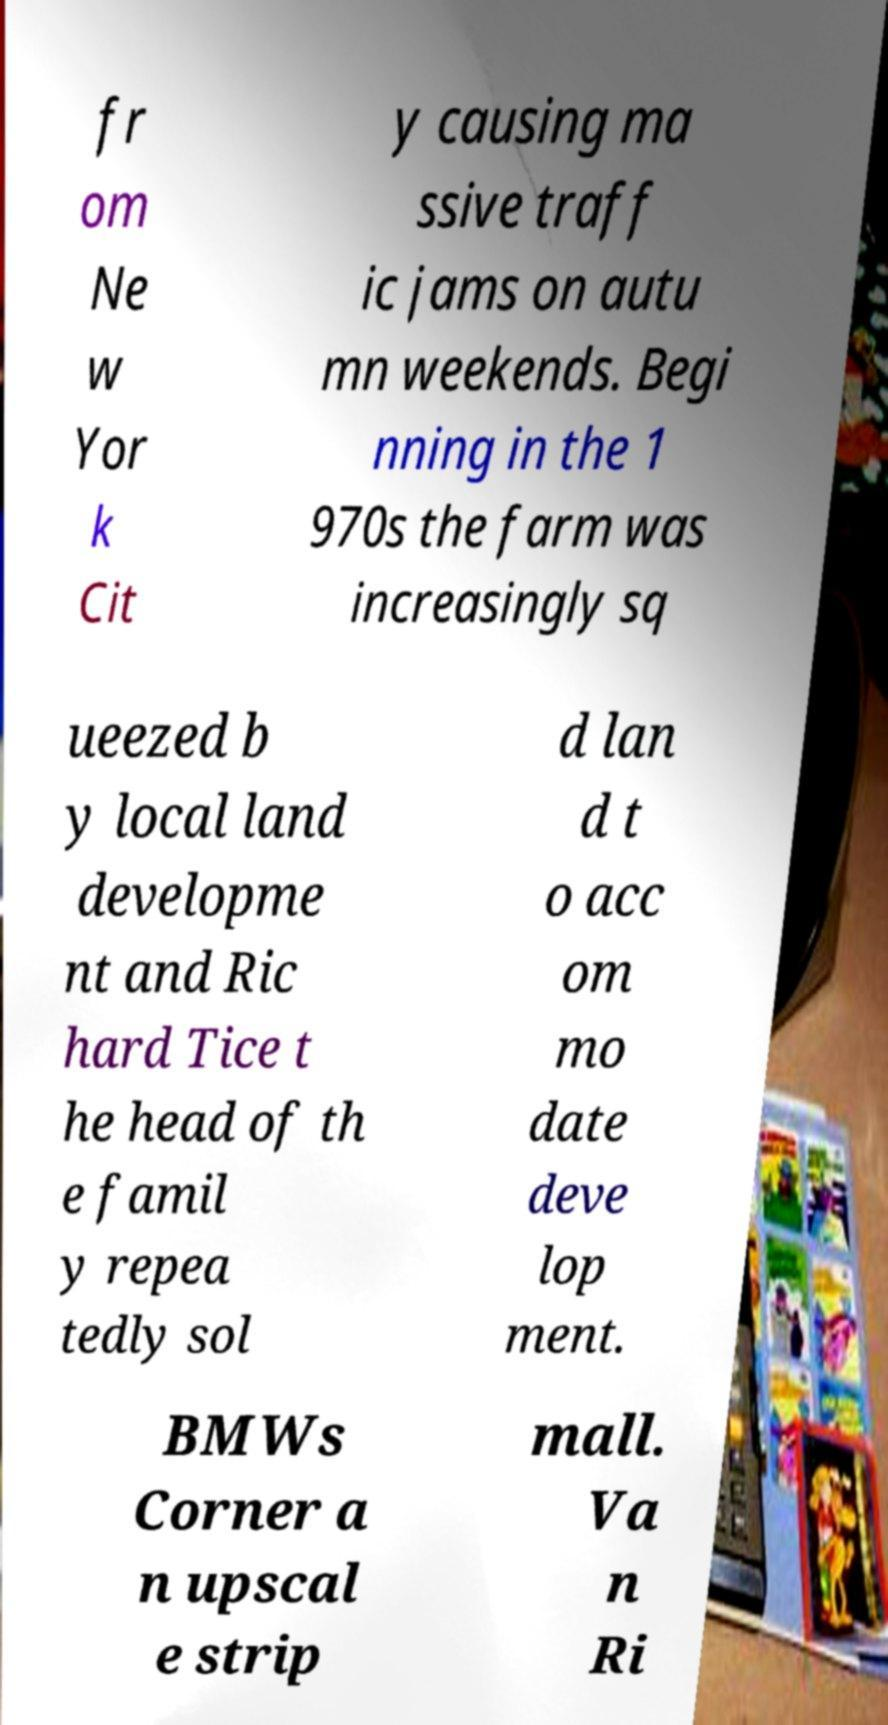Can you read and provide the text displayed in the image?This photo seems to have some interesting text. Can you extract and type it out for me? fr om Ne w Yor k Cit y causing ma ssive traff ic jams on autu mn weekends. Begi nning in the 1 970s the farm was increasingly sq ueezed b y local land developme nt and Ric hard Tice t he head of th e famil y repea tedly sol d lan d t o acc om mo date deve lop ment. BMWs Corner a n upscal e strip mall. Va n Ri 